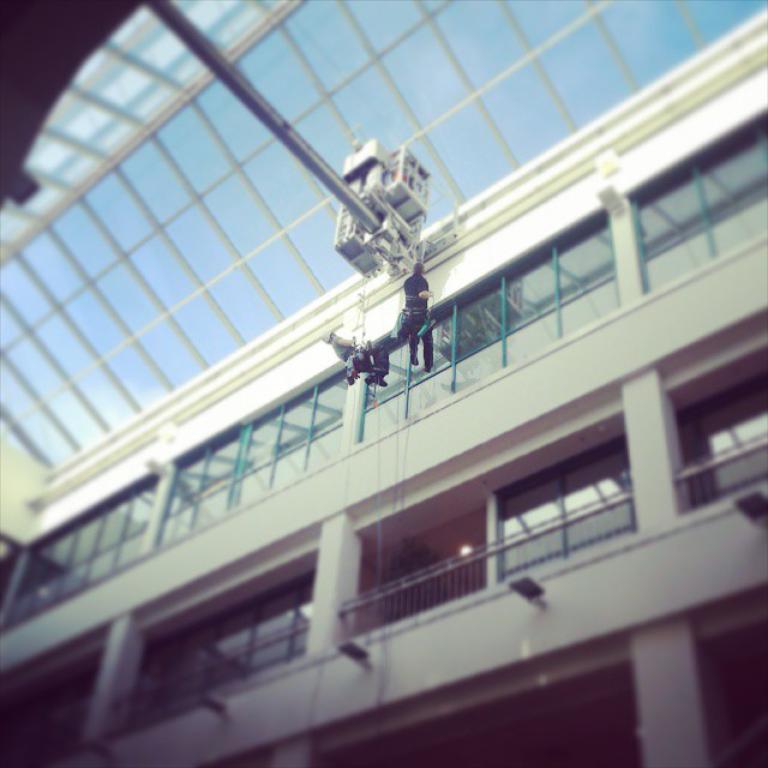Please provide a concise description of this image. There is a building with windows, railings and pillars. And there is a pole with some machine. Also there are two persons hanging on the ropes. 